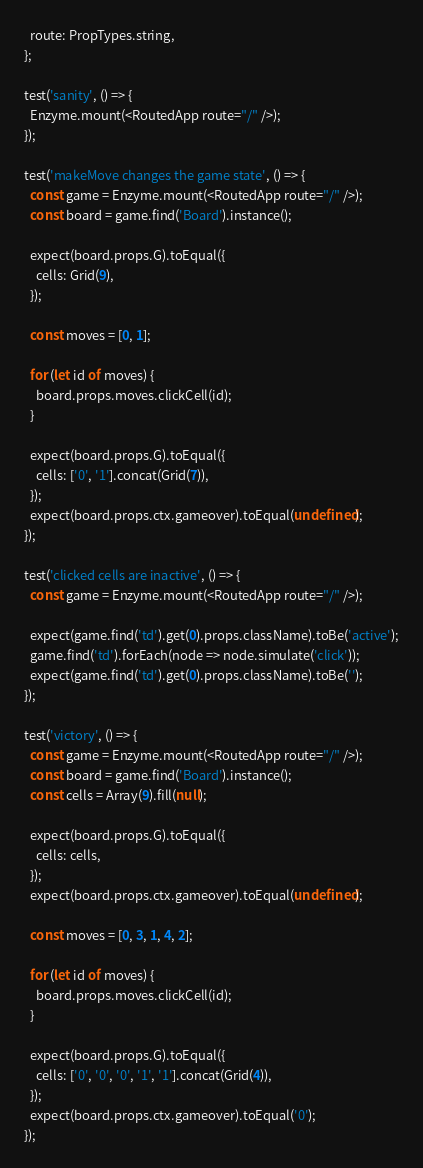Convert code to text. <code><loc_0><loc_0><loc_500><loc_500><_JavaScript_>  route: PropTypes.string,
};

test('sanity', () => {
  Enzyme.mount(<RoutedApp route="/" />);
});

test('makeMove changes the game state', () => {
  const game = Enzyme.mount(<RoutedApp route="/" />);
  const board = game.find('Board').instance();

  expect(board.props.G).toEqual({
    cells: Grid(9),
  });

  const moves = [0, 1];

  for (let id of moves) {
    board.props.moves.clickCell(id);
  }

  expect(board.props.G).toEqual({
    cells: ['0', '1'].concat(Grid(7)),
  });
  expect(board.props.ctx.gameover).toEqual(undefined);
});

test('clicked cells are inactive', () => {
  const game = Enzyme.mount(<RoutedApp route="/" />);

  expect(game.find('td').get(0).props.className).toBe('active');
  game.find('td').forEach(node => node.simulate('click'));
  expect(game.find('td').get(0).props.className).toBe('');
});

test('victory', () => {
  const game = Enzyme.mount(<RoutedApp route="/" />);
  const board = game.find('Board').instance();
  const cells = Array(9).fill(null);

  expect(board.props.G).toEqual({
    cells: cells,
  });
  expect(board.props.ctx.gameover).toEqual(undefined);

  const moves = [0, 3, 1, 4, 2];

  for (let id of moves) {
    board.props.moves.clickCell(id);
  }

  expect(board.props.G).toEqual({
    cells: ['0', '0', '0', '1', '1'].concat(Grid(4)),
  });
  expect(board.props.ctx.gameover).toEqual('0');
});
</code> 